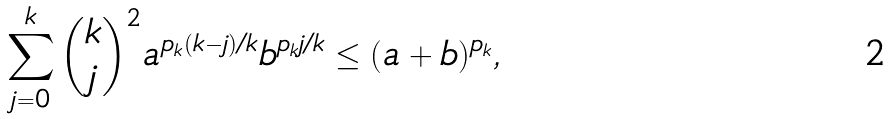Convert formula to latex. <formula><loc_0><loc_0><loc_500><loc_500>\sum _ { j = 0 } ^ { k } \binom { k } { j } ^ { 2 } a ^ { p _ { k } ( k - j ) / k } b ^ { p _ { k } j / k } \leq ( a + b ) ^ { p _ { k } } ,</formula> 